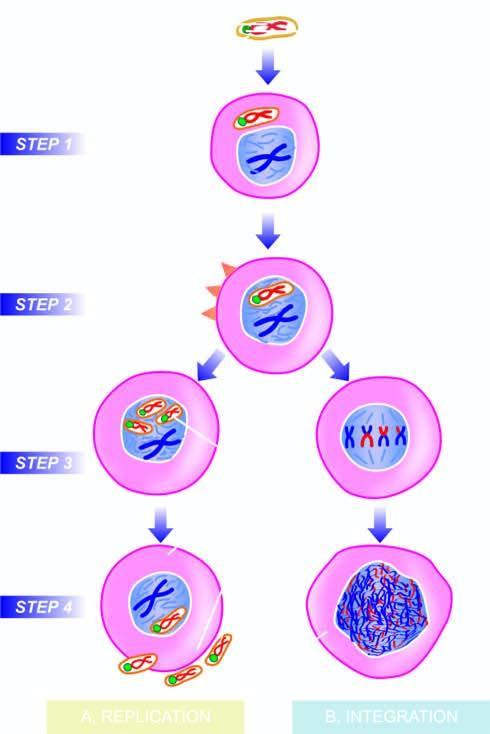what is incorporated into the host nucleus?
Answer the question using a single word or phrase. Viral dna 